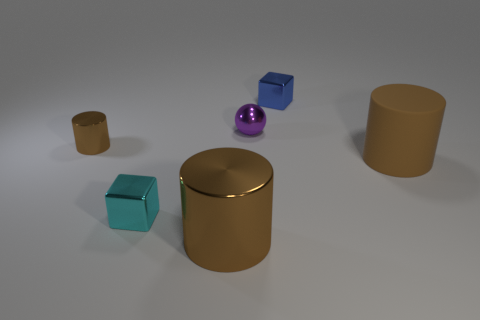There is a metal cylinder that is in front of the small cube in front of the large rubber object; what is its color?
Your response must be concise. Brown. How many blocks are matte objects or small metallic objects?
Offer a terse response. 2. There is a metallic cylinder to the left of the brown metallic cylinder in front of the big rubber cylinder; what number of purple shiny spheres are in front of it?
Your answer should be very brief. 0. What size is the metal thing that is the same color as the small cylinder?
Your answer should be compact. Large. Are there any large cylinders that have the same material as the tiny purple ball?
Provide a succinct answer. Yes. Is the material of the small purple object the same as the blue object?
Your answer should be very brief. Yes. There is a tiny metallic block to the left of the purple object; what number of purple shiny objects are in front of it?
Provide a succinct answer. 0. What number of gray objects are either spheres or cylinders?
Your answer should be very brief. 0. There is a large thing right of the big brown cylinder that is left of the big cylinder behind the tiny cyan shiny cube; what is its shape?
Your response must be concise. Cylinder. The cube that is the same size as the cyan thing is what color?
Provide a succinct answer. Blue. 